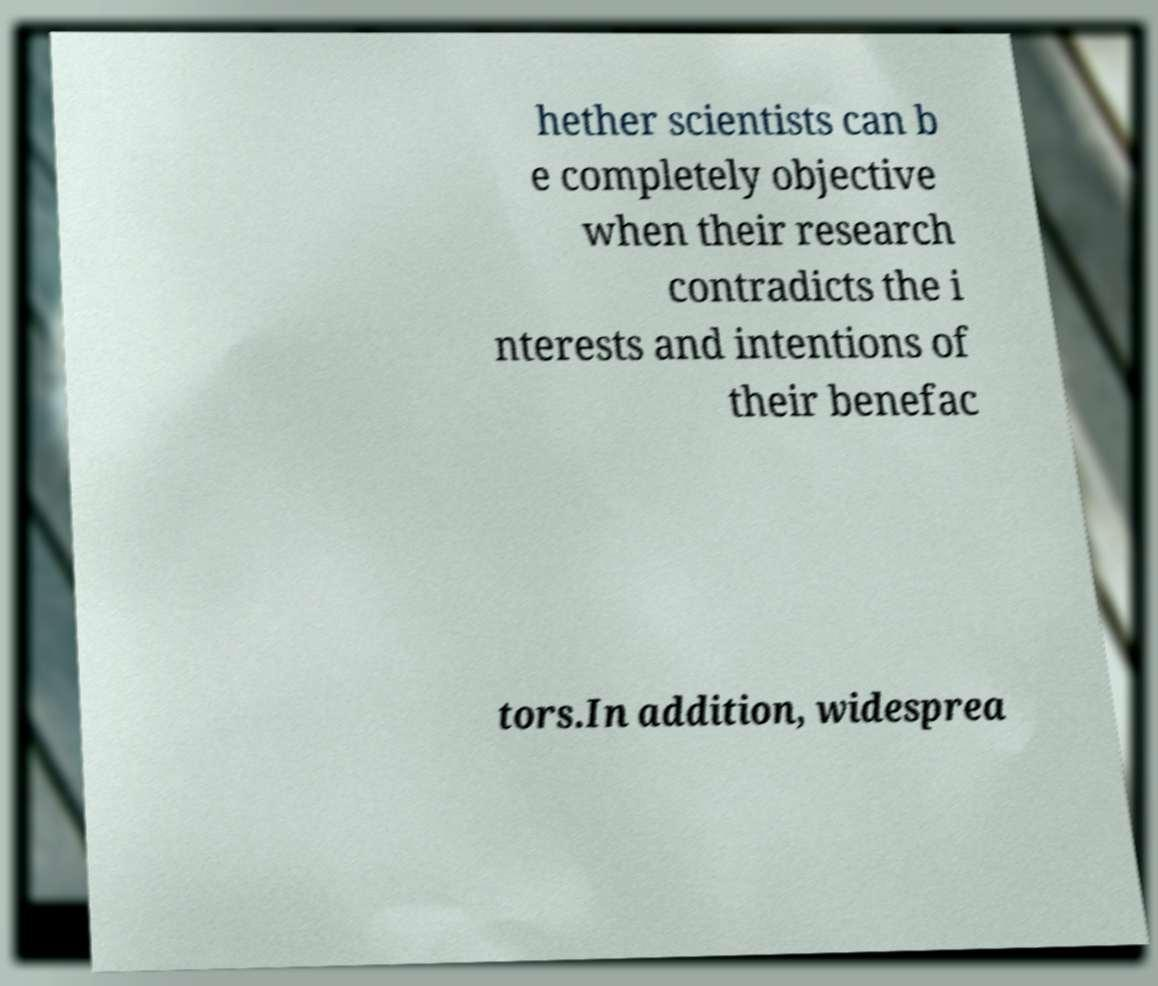What messages or text are displayed in this image? I need them in a readable, typed format. hether scientists can b e completely objective when their research contradicts the i nterests and intentions of their benefac tors.In addition, widesprea 